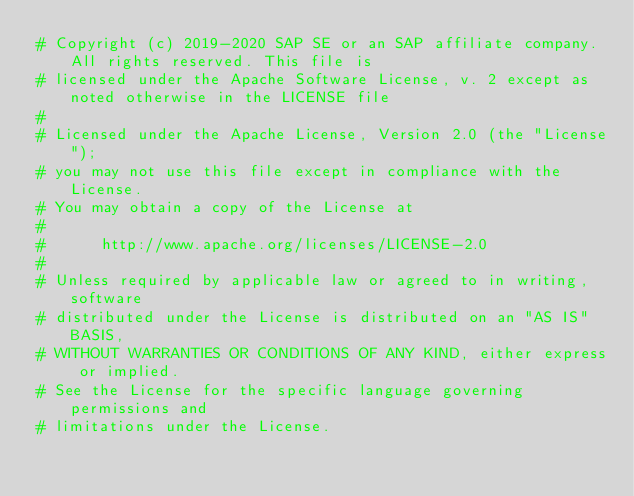<code> <loc_0><loc_0><loc_500><loc_500><_Python_># Copyright (c) 2019-2020 SAP SE or an SAP affiliate company. All rights reserved. This file is
# licensed under the Apache Software License, v. 2 except as noted otherwise in the LICENSE file
#
# Licensed under the Apache License, Version 2.0 (the "License");
# you may not use this file except in compliance with the License.
# You may obtain a copy of the License at
#
#      http://www.apache.org/licenses/LICENSE-2.0
#
# Unless required by applicable law or agreed to in writing, software
# distributed under the License is distributed on an "AS IS" BASIS,
# WITHOUT WARRANTIES OR CONDITIONS OF ANY KIND, either express or implied.
# See the License for the specific language governing permissions and
# limitations under the License.
</code> 